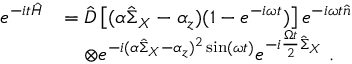<formula> <loc_0><loc_0><loc_500><loc_500>\begin{array} { r l } { e ^ { - i t \hat { H } } } & { = \hat { D } \left [ ( \alpha \hat { \Sigma } _ { X } - \alpha _ { z } ) ( 1 - e ^ { - i \omega t } ) \right ] e ^ { - i \omega t \hat { n } } } \\ & { \quad \otimes e ^ { - i ( \alpha \hat { \Sigma } _ { X } - \alpha _ { z } ) ^ { 2 } \sin ( \omega t ) } e ^ { - i \frac { \Omega t } { 2 } \hat { \Sigma } _ { X } } \ . } \end{array}</formula> 